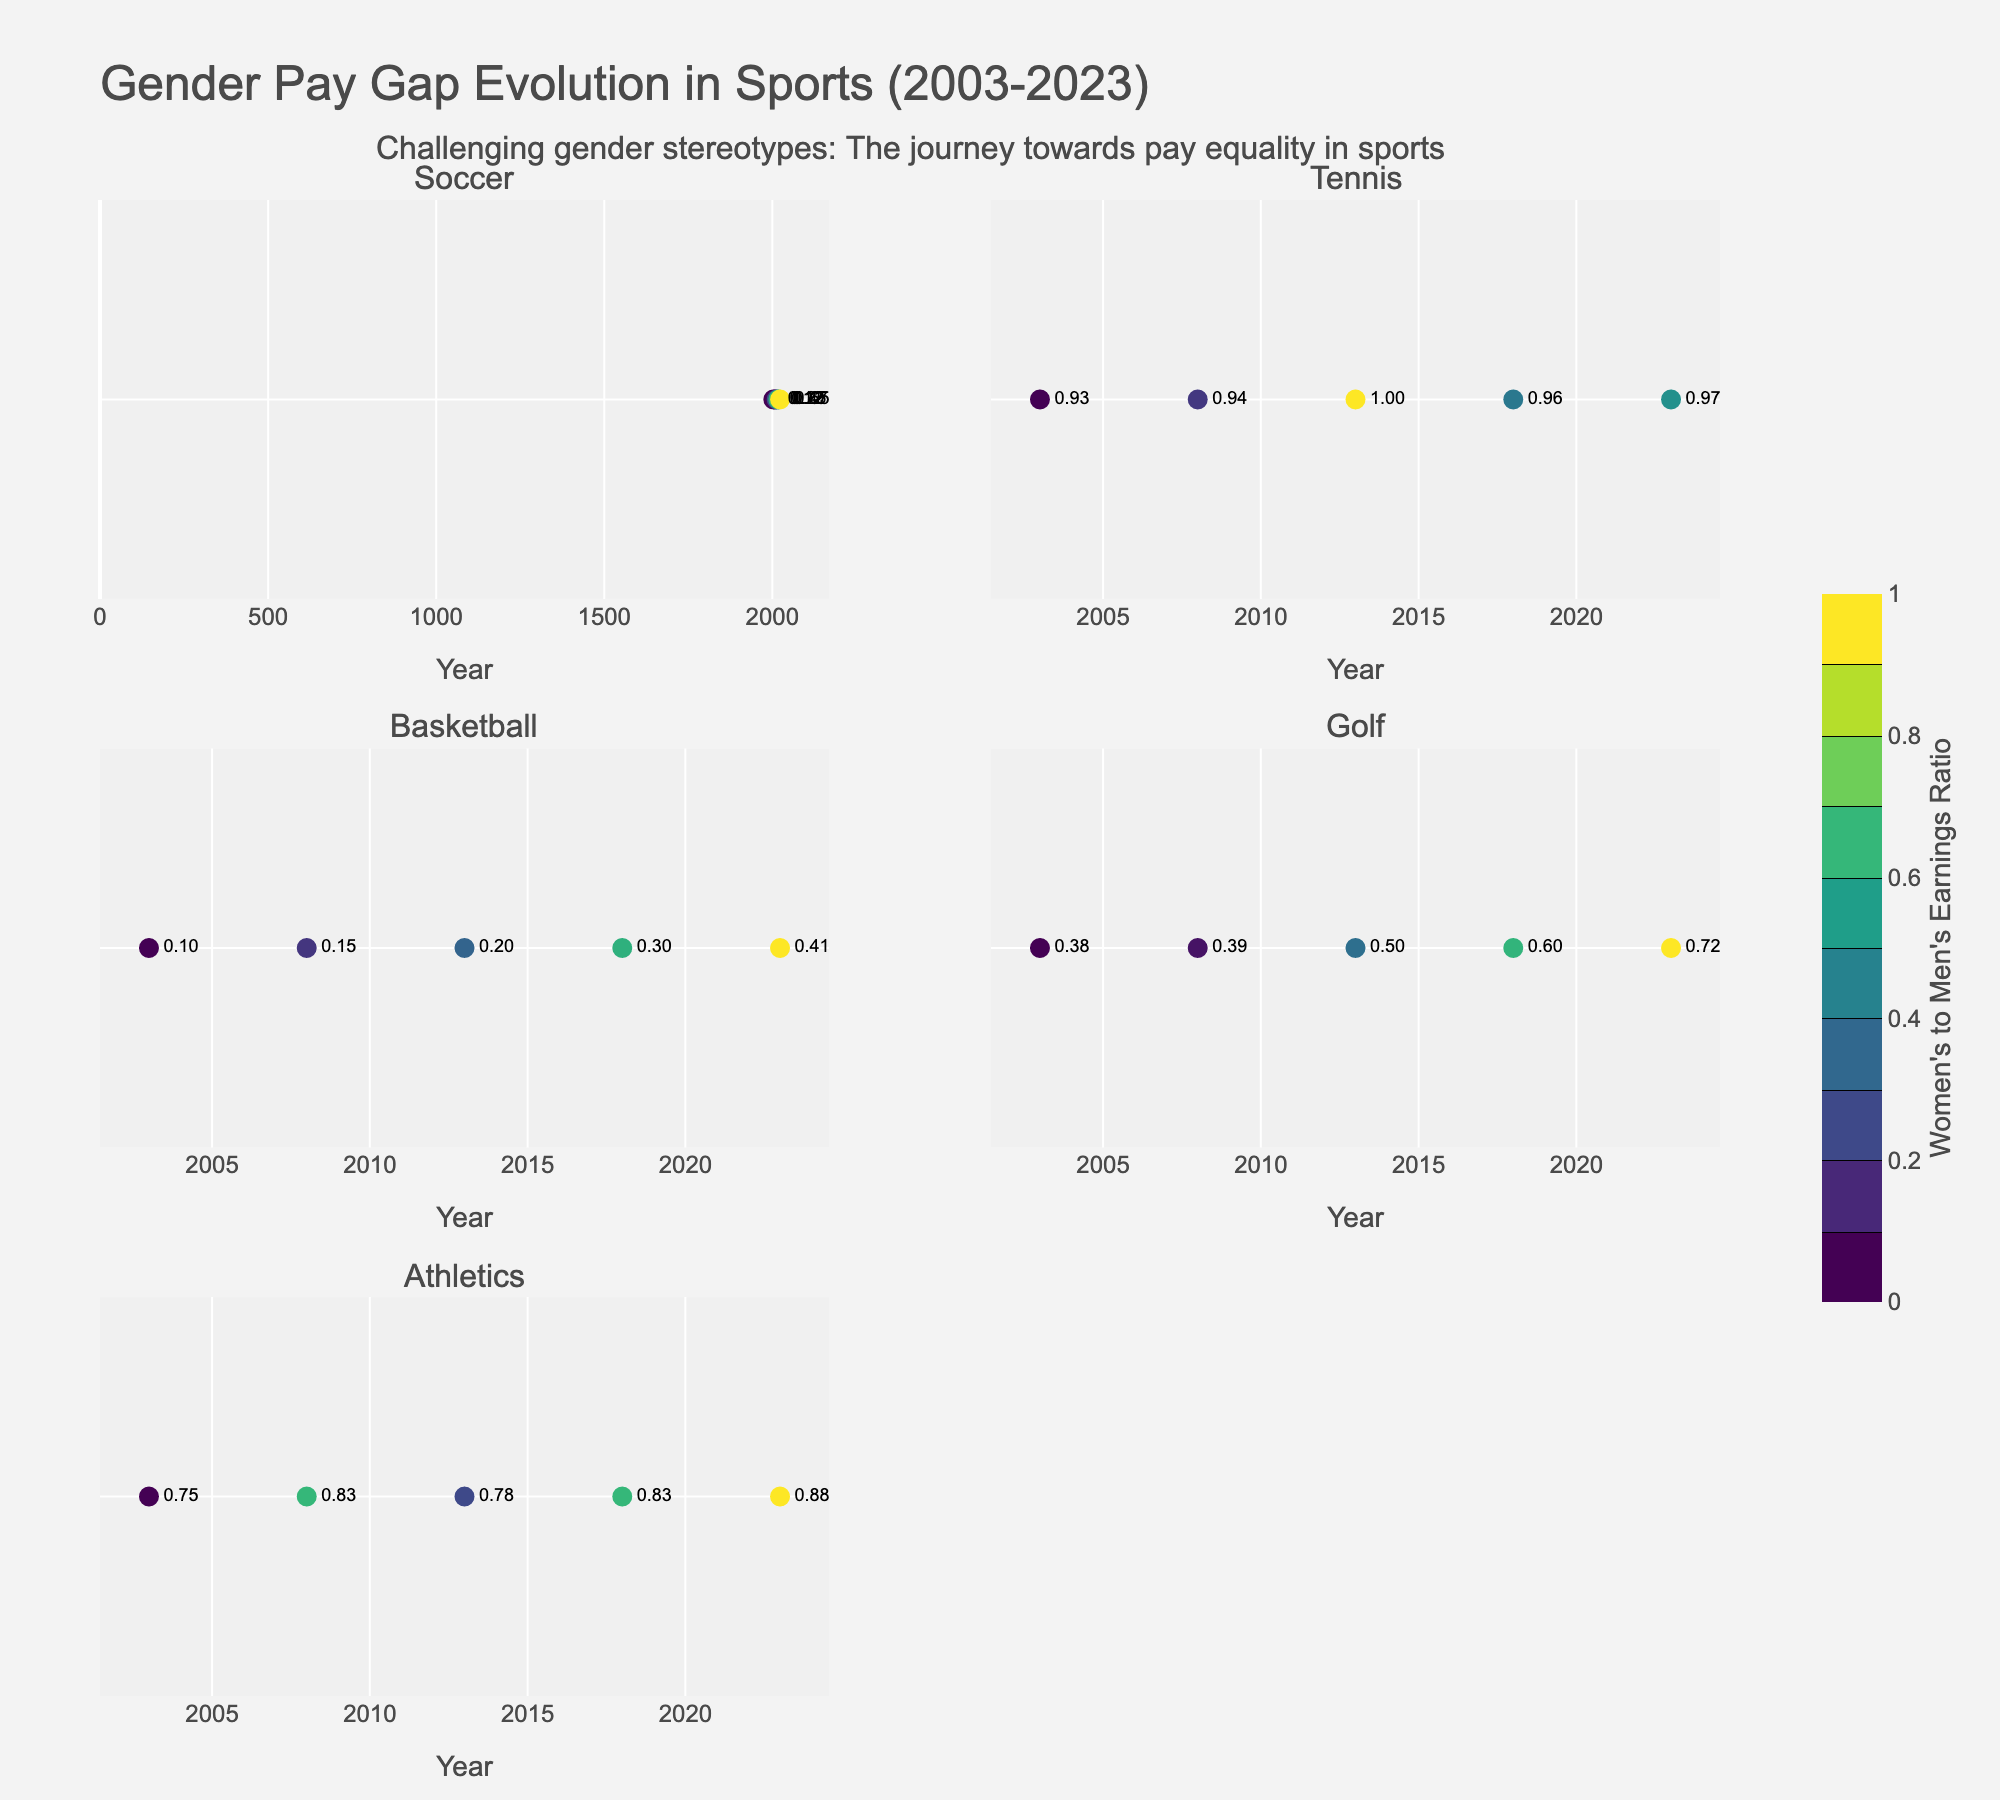what is the title of the plot? The plot's title is displayed prominently at the top center of the plot. From the visual information, it reads "Gender Pay Gap Evolution in Sports (2003-2023)."
Answer: Gender Pay Gap Evolution in Sports (2003-2023) How many sports are analyzed in the subplot? The subplot titles indicate the sports analyzed. Each subplot represents a sport, and there are six subplot titles.
Answer: Six In which sport is the ratio of women's earnings to men's earnings closest to 1 in 2023? The subplot for Tennis shows the women's to men's earnings ratio as close to 1. The marker's text near 2023 shows a value close to 1.
Answer: Tennis Which sport shows the smallest improvement in the gender pay gap from 2003 to 2023 based on the ratios? By looking at the ratios from 2003 to 2023, Basketball shows a significant gap over time with smaller improvements, as indicated by the consistently lower contours and label values.
Answer: Basketball In which sport has the gender pay gap ratio improved the most from 2003 to 2023? Observing the changes in the ratios, Soccer shows considerable improvement given the progressive increase in the ratio seen in the contour labels and markers over the years.
Answer: Soccer What is the women's earnings to men's earnings ratio in Athletics in 2003? The contour and markers in the subplot for Athletics show that the ratio in 2003 is labeled around 0.75.
Answer: 0.75 How does the pay gap in Golf in 2018 compare to 2023? Examining the markers in the Golf subplot for 2018 and 2023, earnings ratio increases from approximately 0.60 to 0.72, indicating an improvement.
Answer: Improved (0.60 to 0.72) Which subplot shows the smallest gender pay gap in both 2003 and 2023? By observing initial and final ratios, Tennis has the smallest pay gap in both years, with margins close to 1 in both cases.
Answer: Tennis Which sport shows a significant marker increase in the ratio from 2013 to 2023? Observing the markers for each sport, Soccer has a substantial increase in the ratio from 2013 to 2023, indicating rapid improvement.
Answer: Soccer 